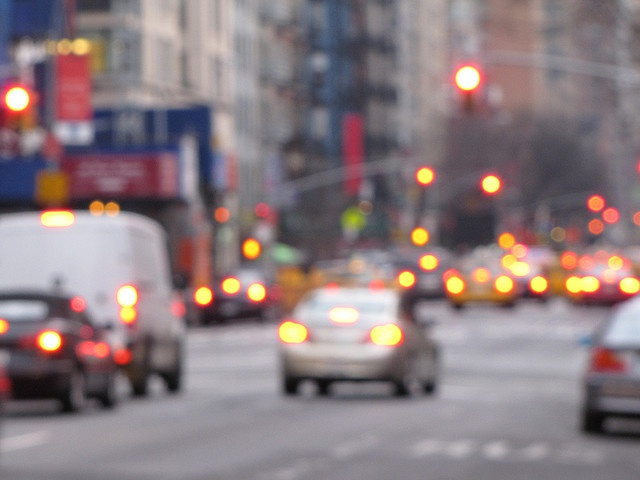Describe the objects in this image and their specific colors. I can see truck in blue, lightgray, darkgray, gray, and black tones, car in blue, lightgray, gray, darkgray, and black tones, car in blue, gray, black, and maroon tones, car in blue, gray, darkgray, lavender, and black tones, and car in blue, darkgray, lightpink, khaki, and brown tones in this image. 